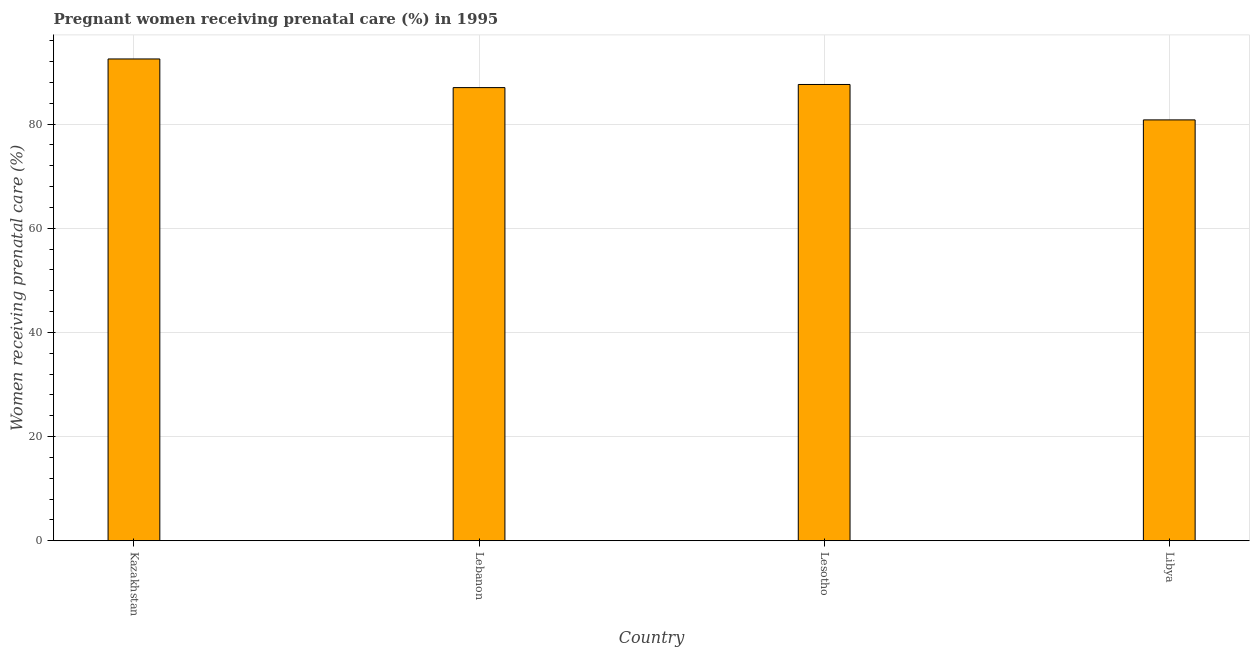What is the title of the graph?
Make the answer very short. Pregnant women receiving prenatal care (%) in 1995. What is the label or title of the X-axis?
Make the answer very short. Country. What is the label or title of the Y-axis?
Keep it short and to the point. Women receiving prenatal care (%). What is the percentage of pregnant women receiving prenatal care in Libya?
Your response must be concise. 80.8. Across all countries, what is the maximum percentage of pregnant women receiving prenatal care?
Your answer should be compact. 92.5. Across all countries, what is the minimum percentage of pregnant women receiving prenatal care?
Your answer should be compact. 80.8. In which country was the percentage of pregnant women receiving prenatal care maximum?
Keep it short and to the point. Kazakhstan. In which country was the percentage of pregnant women receiving prenatal care minimum?
Provide a short and direct response. Libya. What is the sum of the percentage of pregnant women receiving prenatal care?
Provide a succinct answer. 347.9. What is the average percentage of pregnant women receiving prenatal care per country?
Provide a succinct answer. 86.97. What is the median percentage of pregnant women receiving prenatal care?
Offer a terse response. 87.3. What is the ratio of the percentage of pregnant women receiving prenatal care in Lesotho to that in Libya?
Give a very brief answer. 1.08. Is the difference between the percentage of pregnant women receiving prenatal care in Kazakhstan and Libya greater than the difference between any two countries?
Keep it short and to the point. Yes. What is the difference between the highest and the second highest percentage of pregnant women receiving prenatal care?
Ensure brevity in your answer.  4.9. Is the sum of the percentage of pregnant women receiving prenatal care in Kazakhstan and Lebanon greater than the maximum percentage of pregnant women receiving prenatal care across all countries?
Ensure brevity in your answer.  Yes. What is the difference between the highest and the lowest percentage of pregnant women receiving prenatal care?
Provide a short and direct response. 11.7. How many bars are there?
Offer a terse response. 4. Are all the bars in the graph horizontal?
Provide a short and direct response. No. How many countries are there in the graph?
Ensure brevity in your answer.  4. What is the difference between two consecutive major ticks on the Y-axis?
Ensure brevity in your answer.  20. Are the values on the major ticks of Y-axis written in scientific E-notation?
Make the answer very short. No. What is the Women receiving prenatal care (%) of Kazakhstan?
Your answer should be very brief. 92.5. What is the Women receiving prenatal care (%) in Lebanon?
Offer a terse response. 87. What is the Women receiving prenatal care (%) of Lesotho?
Your answer should be compact. 87.6. What is the Women receiving prenatal care (%) of Libya?
Offer a very short reply. 80.8. What is the difference between the Women receiving prenatal care (%) in Kazakhstan and Lesotho?
Keep it short and to the point. 4.9. What is the difference between the Women receiving prenatal care (%) in Lebanon and Lesotho?
Your answer should be very brief. -0.6. What is the difference between the Women receiving prenatal care (%) in Lebanon and Libya?
Your answer should be compact. 6.2. What is the ratio of the Women receiving prenatal care (%) in Kazakhstan to that in Lebanon?
Give a very brief answer. 1.06. What is the ratio of the Women receiving prenatal care (%) in Kazakhstan to that in Lesotho?
Your answer should be compact. 1.06. What is the ratio of the Women receiving prenatal care (%) in Kazakhstan to that in Libya?
Provide a short and direct response. 1.15. What is the ratio of the Women receiving prenatal care (%) in Lebanon to that in Lesotho?
Your answer should be very brief. 0.99. What is the ratio of the Women receiving prenatal care (%) in Lebanon to that in Libya?
Offer a terse response. 1.08. What is the ratio of the Women receiving prenatal care (%) in Lesotho to that in Libya?
Your response must be concise. 1.08. 